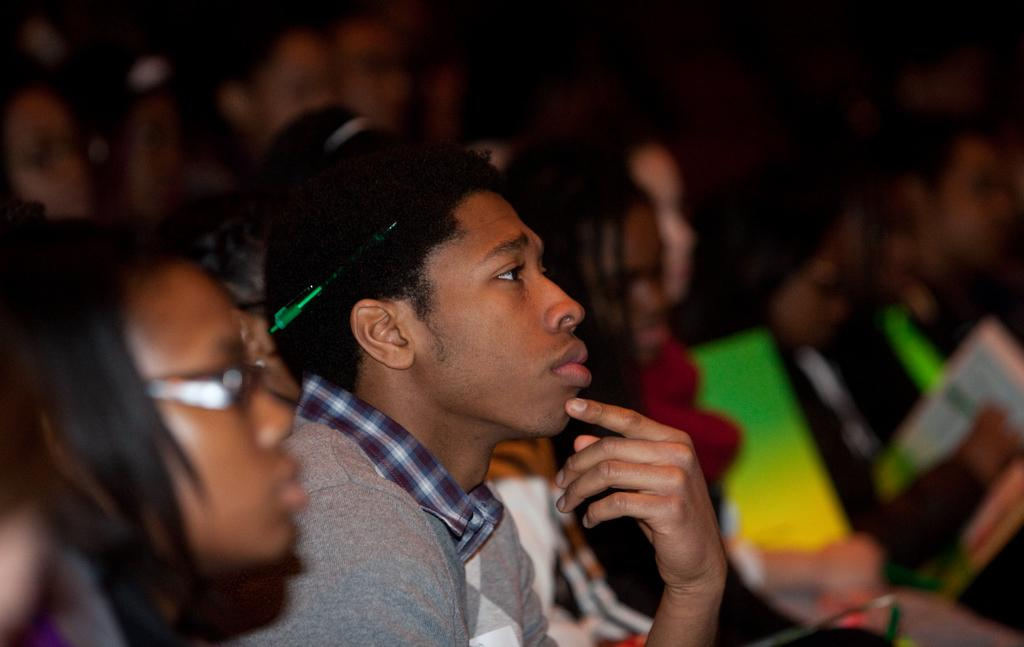What are the people in the image doing? There are people seated in the image. What objects are some of the people holding? Some of the people are holding books. What type of chalk is being used by the people in the image? There is no chalk present in the image; the people are holding books. Can you see any fangs on the people in the image? There are no fangs visible on the people in the image. 